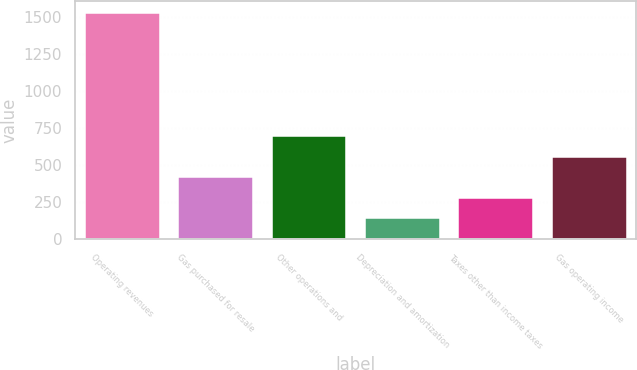Convert chart. <chart><loc_0><loc_0><loc_500><loc_500><bar_chart><fcel>Operating revenues<fcel>Gas purchased for resale<fcel>Other operations and<fcel>Depreciation and amortization<fcel>Taxes other than income taxes<fcel>Gas operating income<nl><fcel>1527<fcel>419<fcel>696<fcel>142<fcel>280.5<fcel>557.5<nl></chart> 